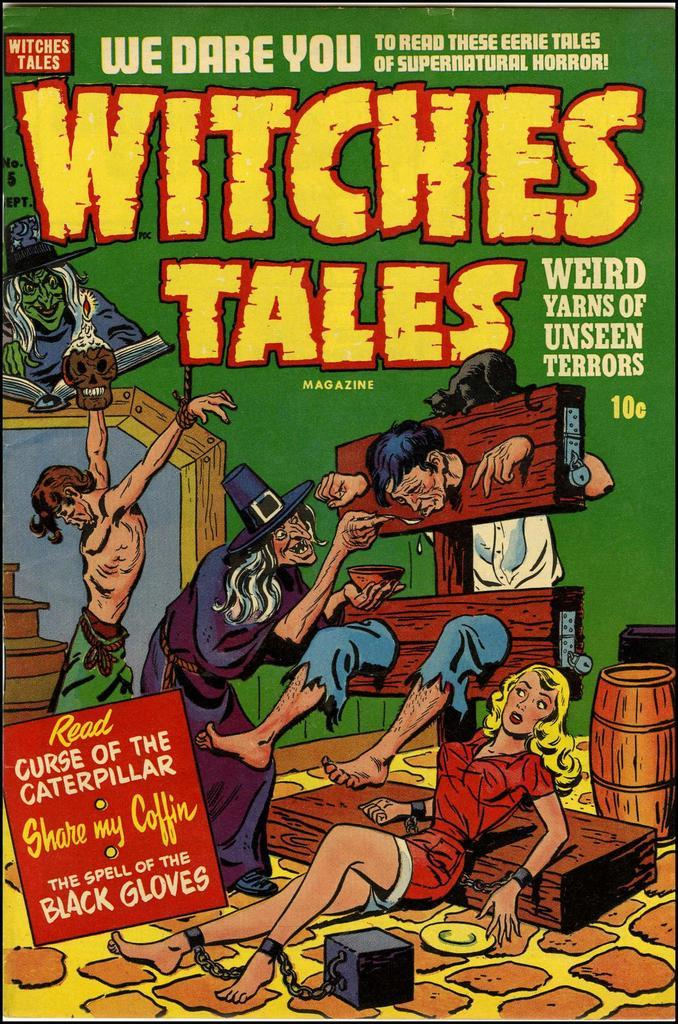<image>
Render a clear and concise summary of the photo. The front cover of Witches Tales has a person in a stockade. 